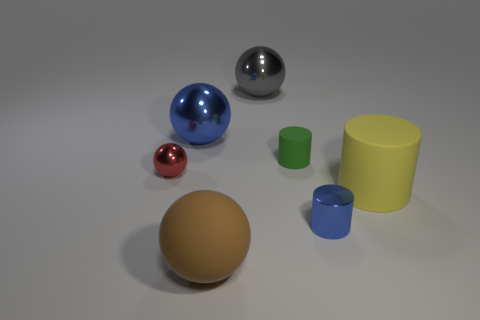Are there an equal number of tiny red metallic objects to the right of the blue cylinder and blue metallic balls that are right of the blue ball?
Provide a short and direct response. Yes. How many other objects are the same color as the big cylinder?
Your answer should be very brief. 0. Are there an equal number of tiny red objects behind the red ball and tiny green things?
Provide a short and direct response. No. Does the green rubber cylinder have the same size as the yellow rubber cylinder?
Offer a terse response. No. The sphere that is both behind the metallic cylinder and in front of the blue ball is made of what material?
Ensure brevity in your answer.  Metal. What number of other tiny objects have the same shape as the green thing?
Offer a terse response. 1. What is the material of the blue thing that is left of the tiny rubber cylinder?
Give a very brief answer. Metal. Is the number of gray metal spheres in front of the big gray sphere less than the number of gray metal things?
Keep it short and to the point. Yes. Is the red object the same shape as the big brown thing?
Provide a short and direct response. Yes. Are there any other things that have the same shape as the yellow object?
Provide a short and direct response. Yes. 